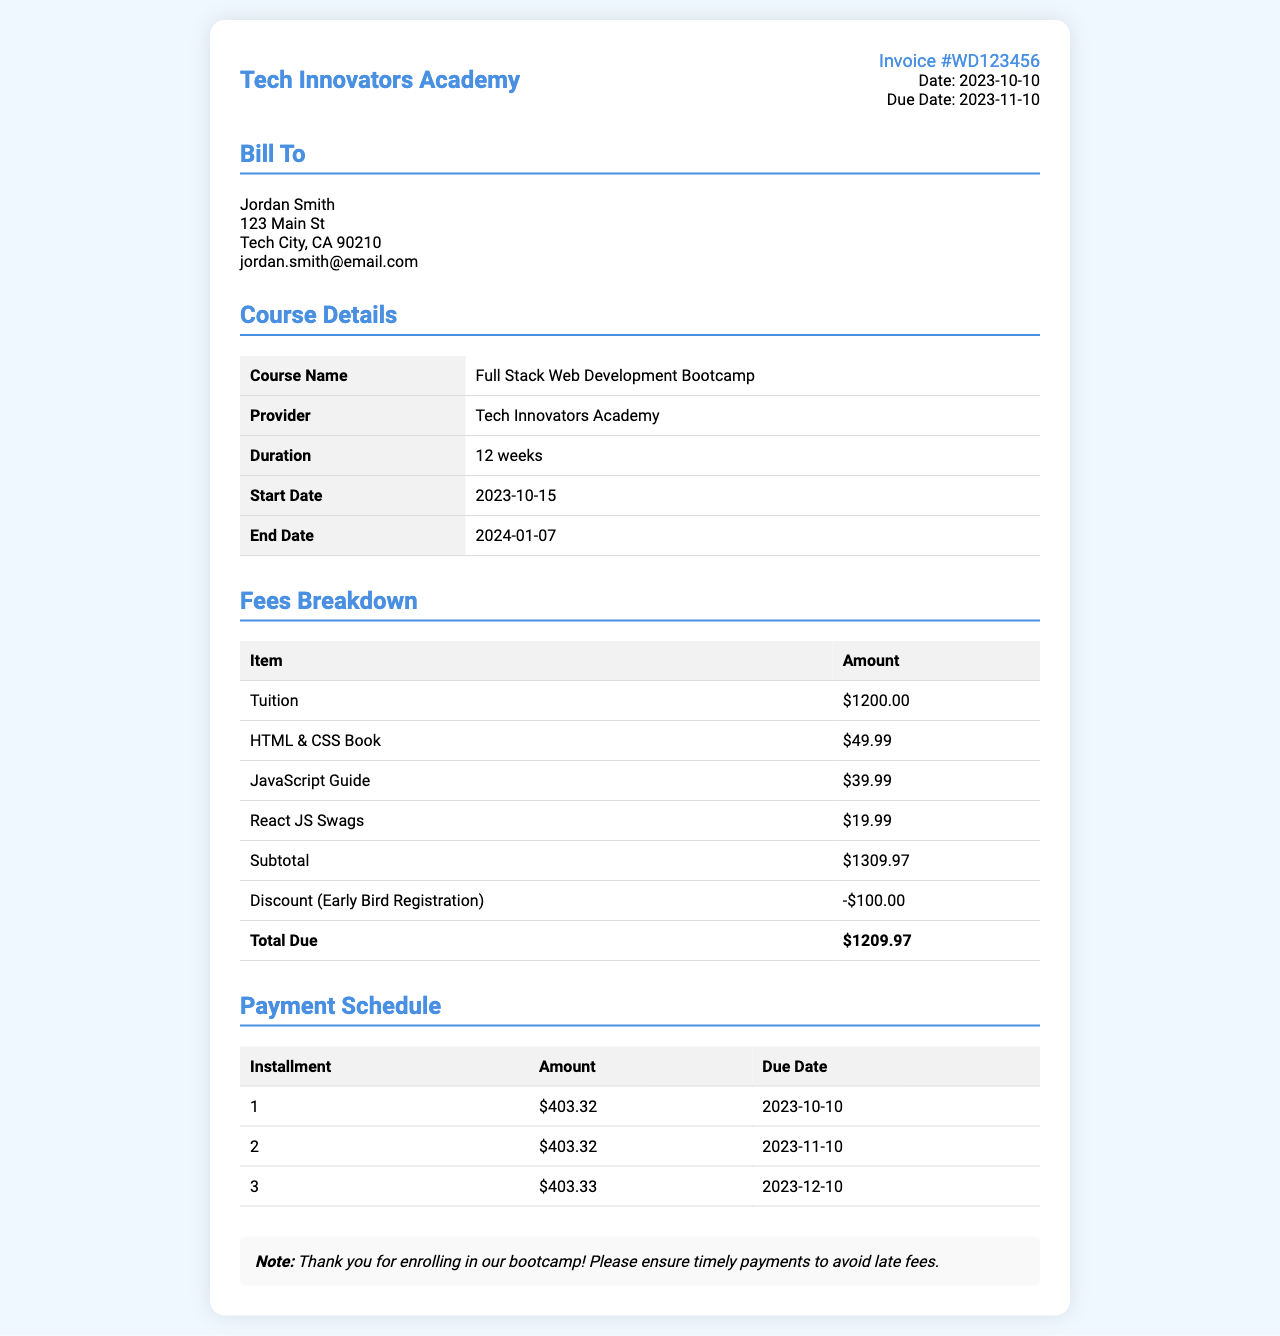What is the invoice number? The invoice number is listed prominently in the document for easy reference.
Answer: WD123456 What is the total due amount? The total due amount is calculated from the fees breakdown section of the invoice.
Answer: $1209.97 When does the course start? The start date for the course is provided in the course details section.
Answer: 2023-10-15 What is the name of the course? The course name is clearly stated in the course details section of the document.
Answer: Full Stack Web Development Bootcamp How much is the discount received? The discount amount is indicated in the fees breakdown section and is subtracted from the subtotal.
Answer: -$100.00 What is the duration of the course? The duration is specified under the course details, providing a timeframe for the course length.
Answer: 12 weeks How many installments are there? The number of installments is detailed in the payment schedule section of the invoice.
Answer: 3 What is the amount of the first installment? The amount for the first installment is listed in the payment schedule section.
Answer: $403.32 When is the second installment due? The due date for the second installment is given in the payment schedule for clarity on payment deadlines.
Answer: 2023-11-10 